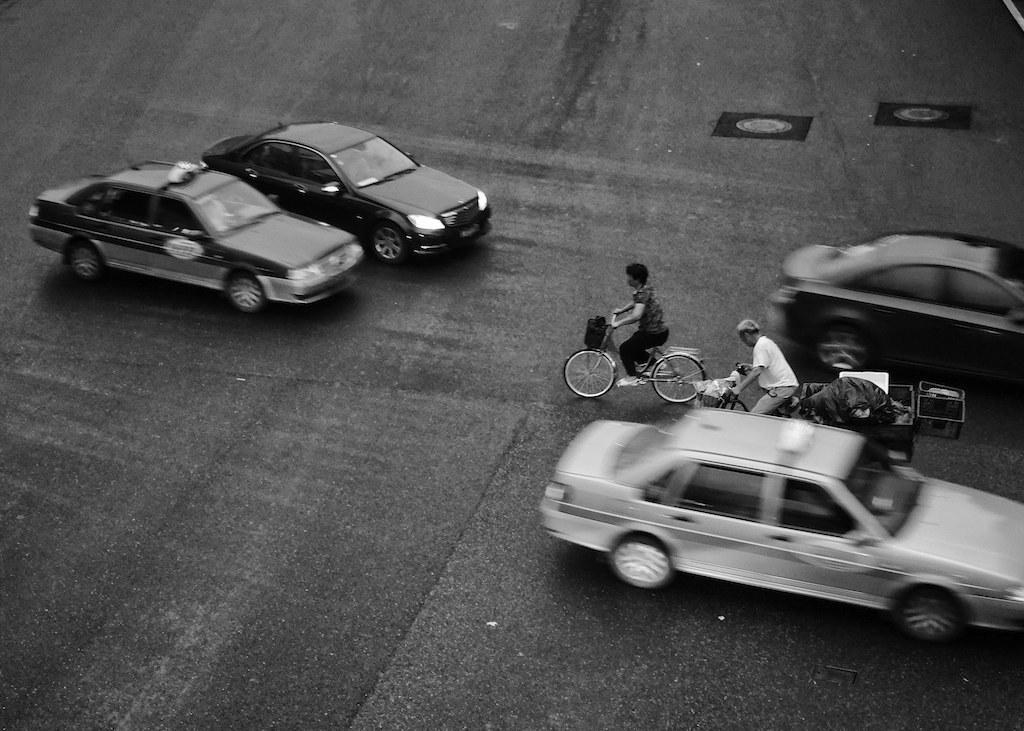How would you summarize this image in a sentence or two? In this image we can see vehicle are moving on the road and also there are two people riding bicycles. 